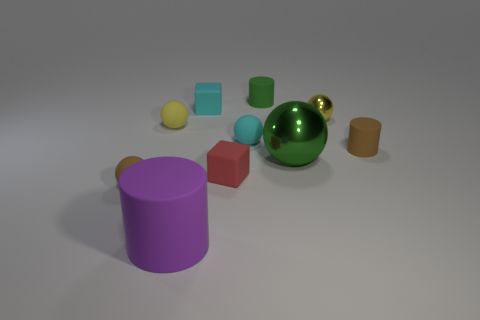Are there more tiny metal objects on the left side of the cyan rubber cube than tiny yellow things right of the tiny green matte object?
Provide a short and direct response. No. What color is the large object behind the red rubber block?
Your answer should be compact. Green. There is a small brown matte object that is in front of the tiny brown matte cylinder; is it the same shape as the tiny matte object that is on the right side of the green shiny object?
Provide a succinct answer. No. Are there any brown things that have the same size as the green rubber cylinder?
Provide a short and direct response. Yes. There is a tiny brown thing that is on the right side of the tiny green rubber object; what is its material?
Your answer should be very brief. Rubber. Does the yellow ball that is right of the green cylinder have the same material as the tiny cyan block?
Keep it short and to the point. No. Are any tiny yellow matte blocks visible?
Your answer should be compact. No. What color is the big object that is the same material as the small brown cylinder?
Your response must be concise. Purple. There is a cylinder that is behind the matte sphere right of the small cyan matte object that is behind the small metal object; what color is it?
Offer a terse response. Green. Is the size of the red block the same as the rubber cylinder that is in front of the large green thing?
Provide a succinct answer. No. 